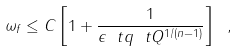Convert formula to latex. <formula><loc_0><loc_0><loc_500><loc_500>\omega _ { f } \leq C \left [ 1 + \frac { 1 } { \epsilon \ t q \ t Q ^ { 1 / ( n - 1 ) } } \right ] \ ,</formula> 